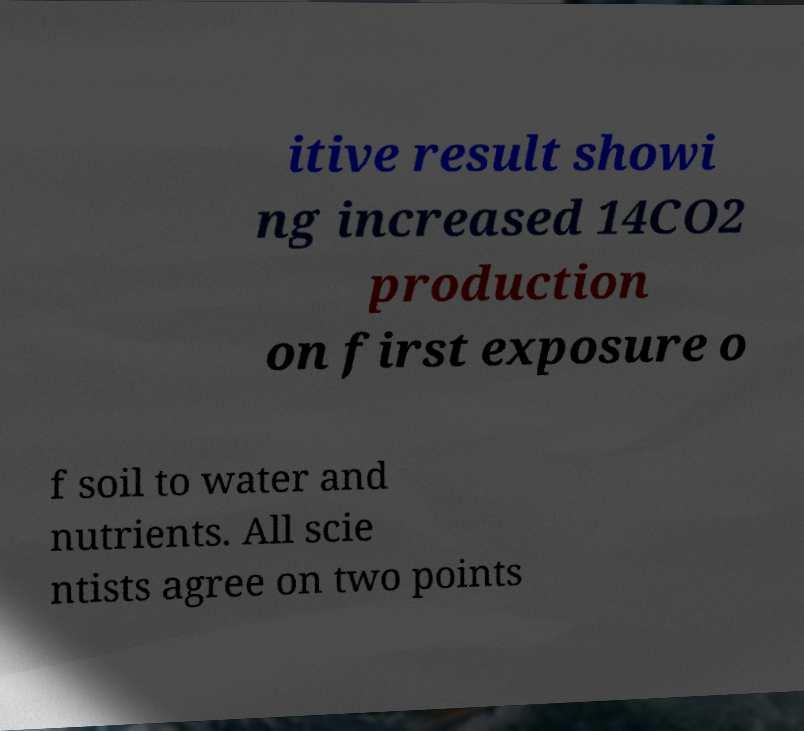Could you extract and type out the text from this image? itive result showi ng increased 14CO2 production on first exposure o f soil to water and nutrients. All scie ntists agree on two points 